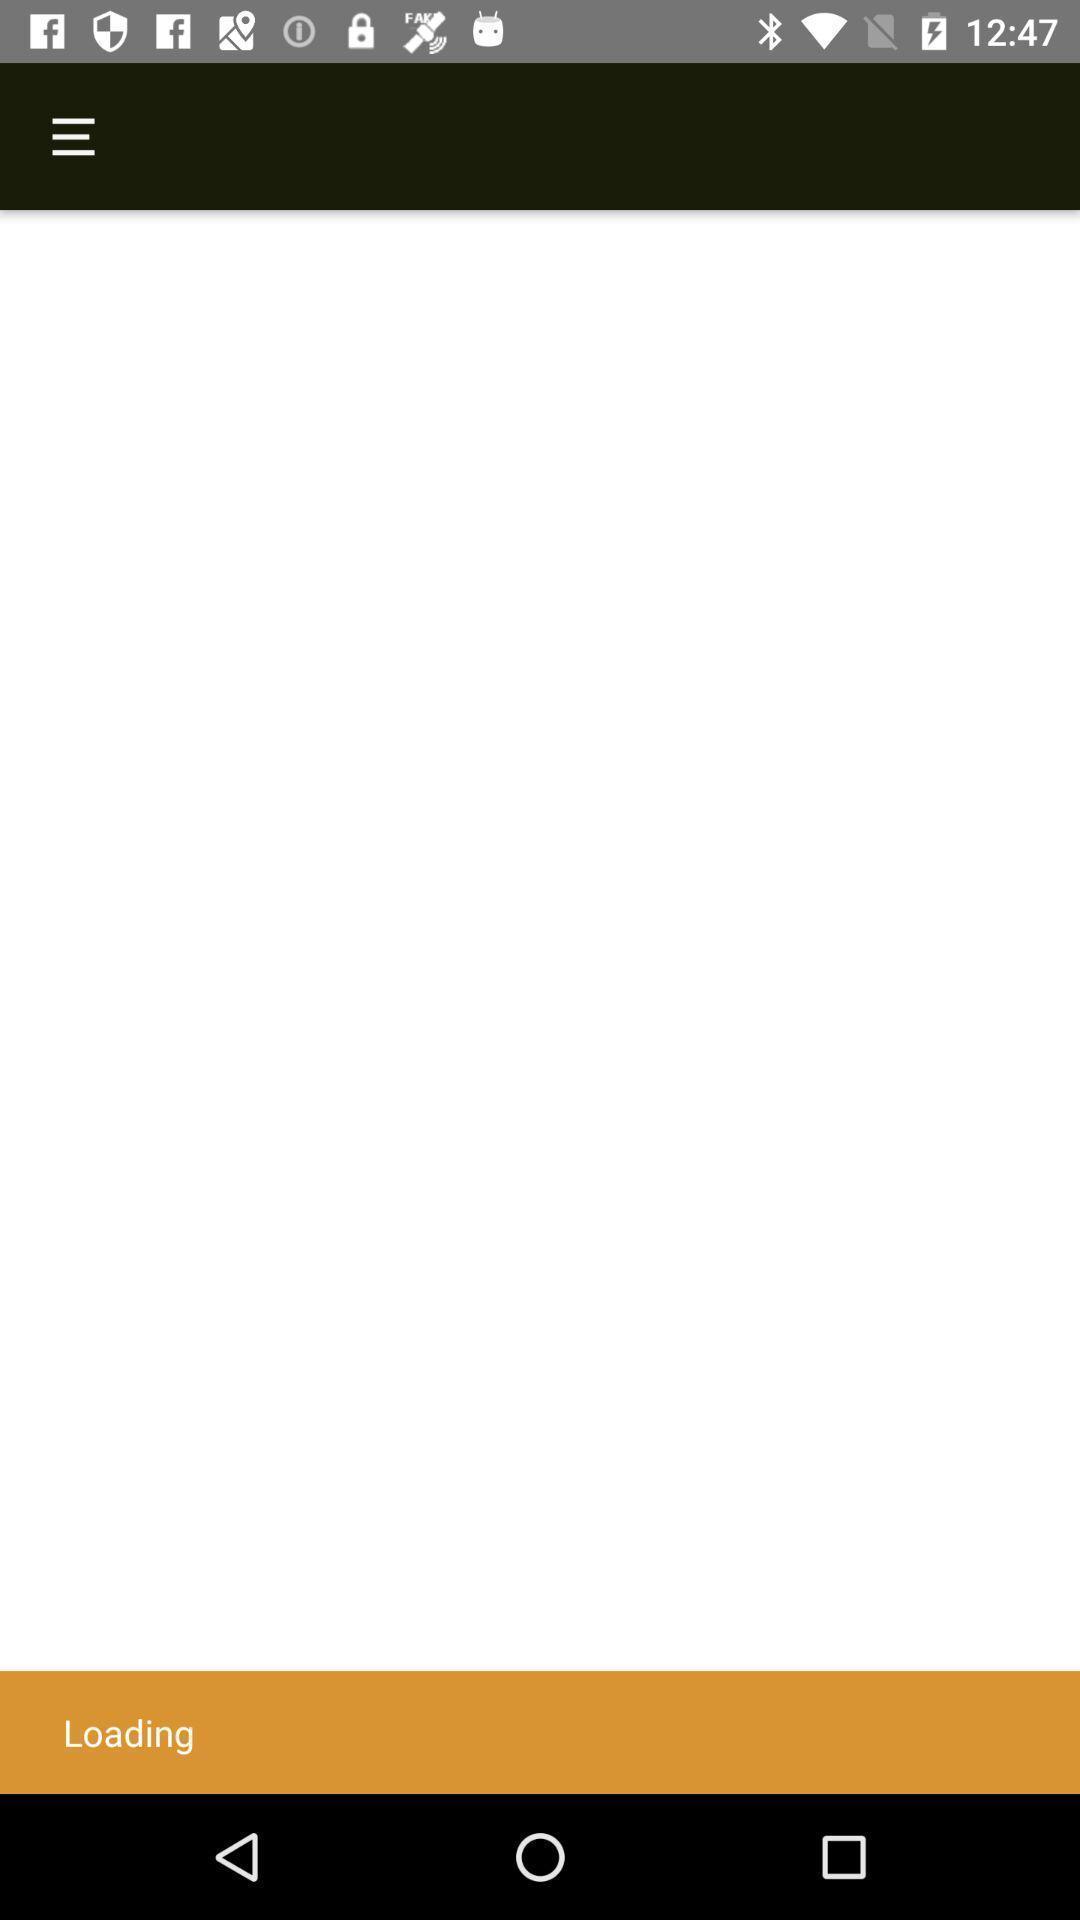What can you discern from this picture? Loading page. 